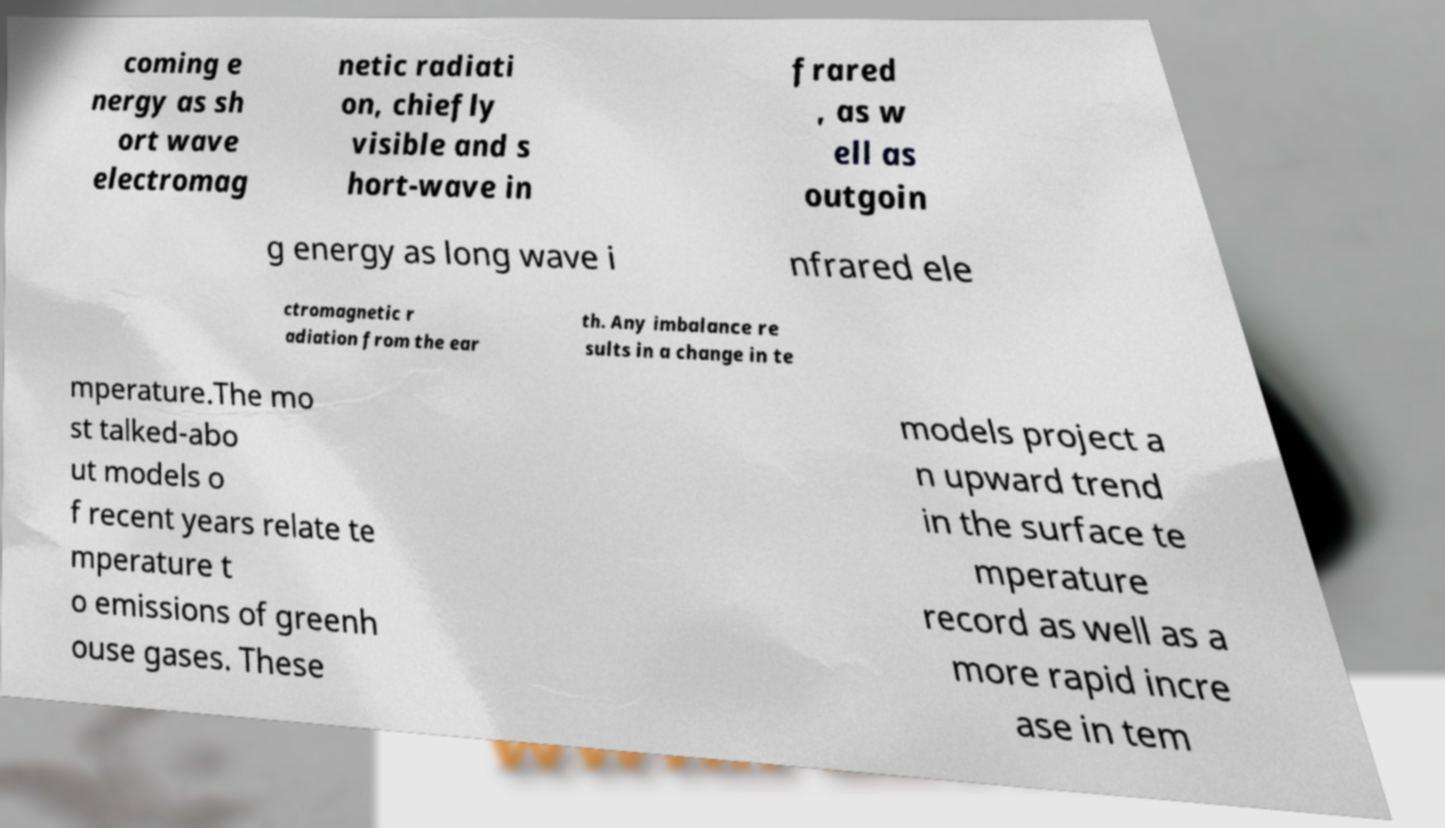What messages or text are displayed in this image? I need them in a readable, typed format. coming e nergy as sh ort wave electromag netic radiati on, chiefly visible and s hort-wave in frared , as w ell as outgoin g energy as long wave i nfrared ele ctromagnetic r adiation from the ear th. Any imbalance re sults in a change in te mperature.The mo st talked-abo ut models o f recent years relate te mperature t o emissions of greenh ouse gases. These models project a n upward trend in the surface te mperature record as well as a more rapid incre ase in tem 